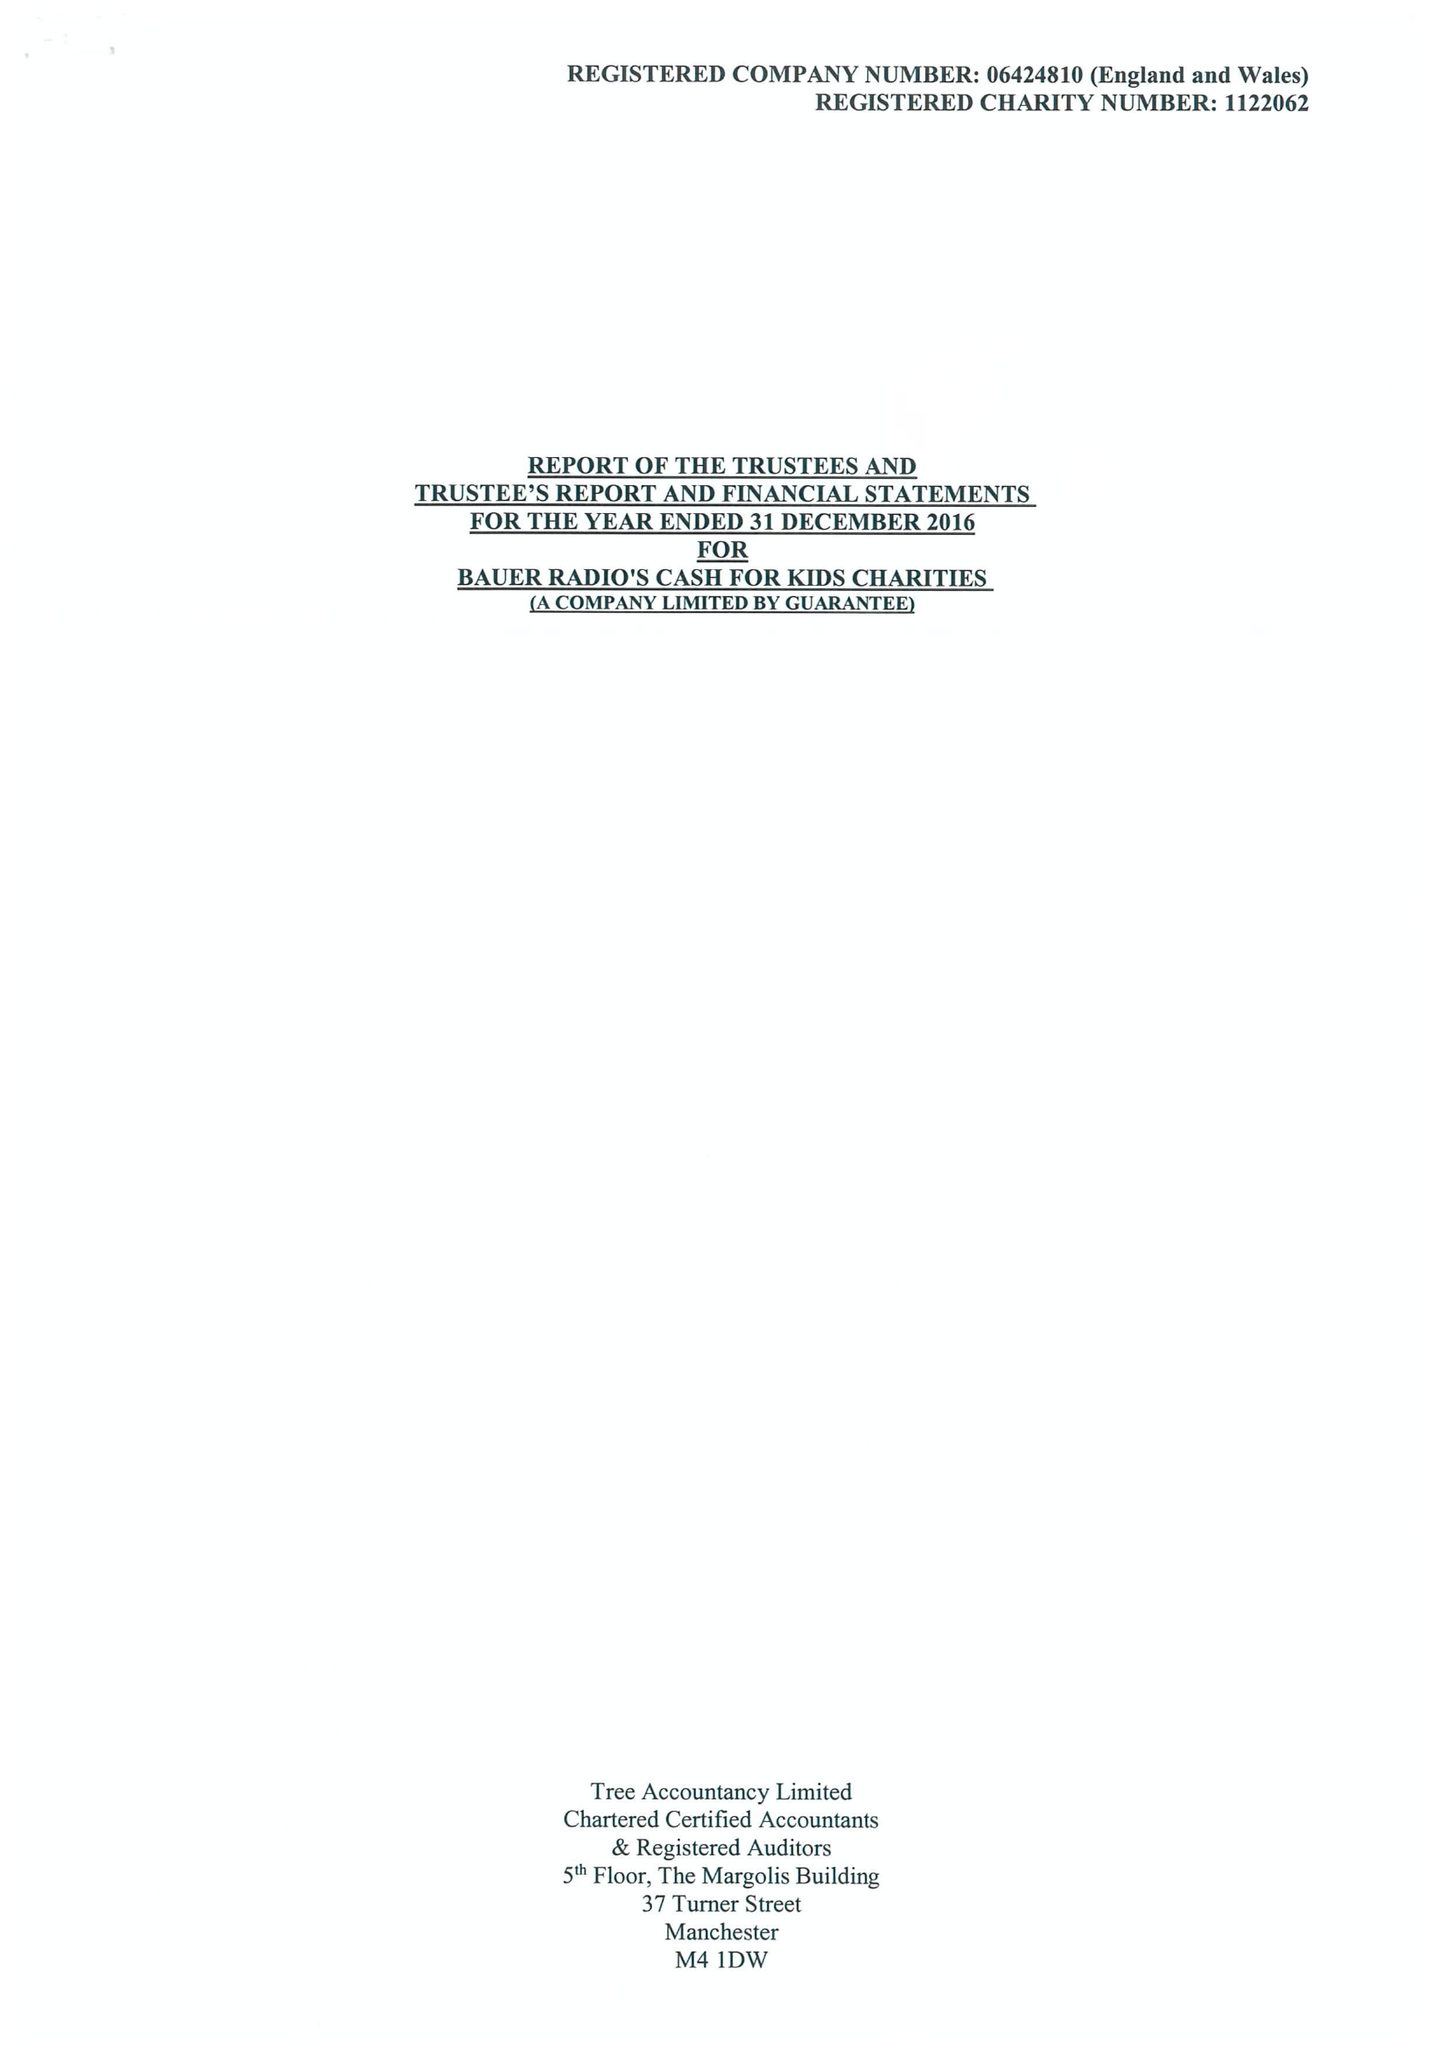What is the value for the charity_number?
Answer the question using a single word or phrase. 1122062 